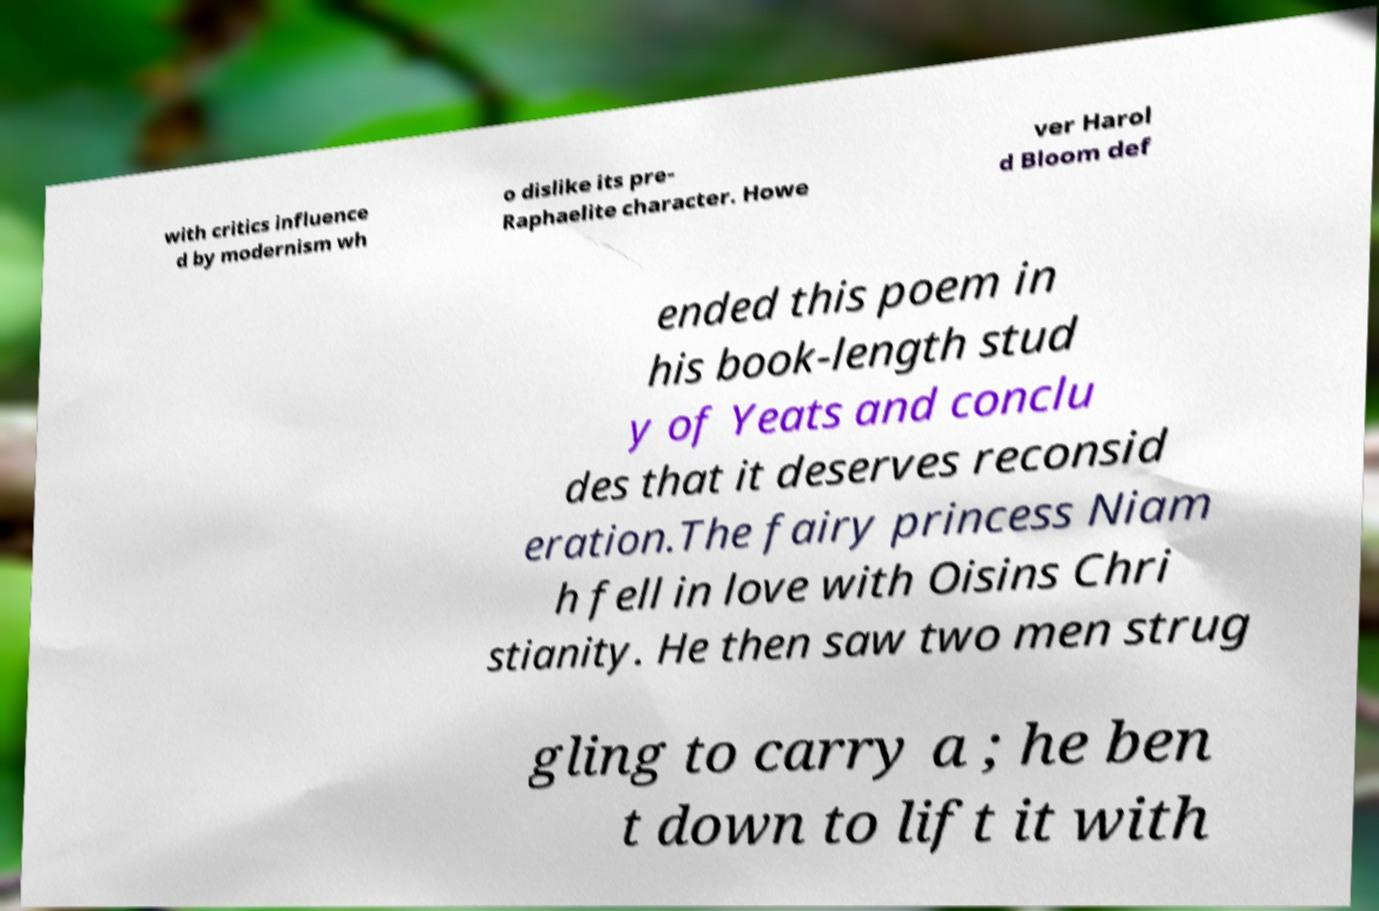Could you assist in decoding the text presented in this image and type it out clearly? with critics influence d by modernism wh o dislike its pre- Raphaelite character. Howe ver Harol d Bloom def ended this poem in his book-length stud y of Yeats and conclu des that it deserves reconsid eration.The fairy princess Niam h fell in love with Oisins Chri stianity. He then saw two men strug gling to carry a ; he ben t down to lift it with 